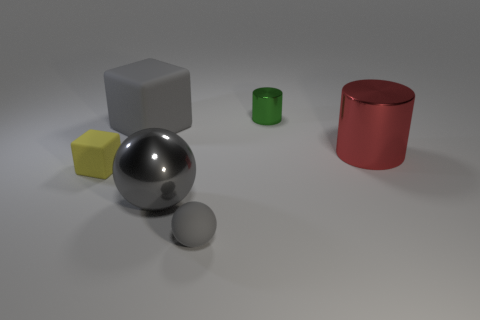Add 1 tiny cubes. How many objects exist? 7 Subtract all blocks. How many objects are left? 4 Add 3 small green cylinders. How many small green cylinders are left? 4 Add 5 tiny green matte blocks. How many tiny green matte blocks exist? 5 Subtract 1 green cylinders. How many objects are left? 5 Subtract all large gray objects. Subtract all gray matte objects. How many objects are left? 2 